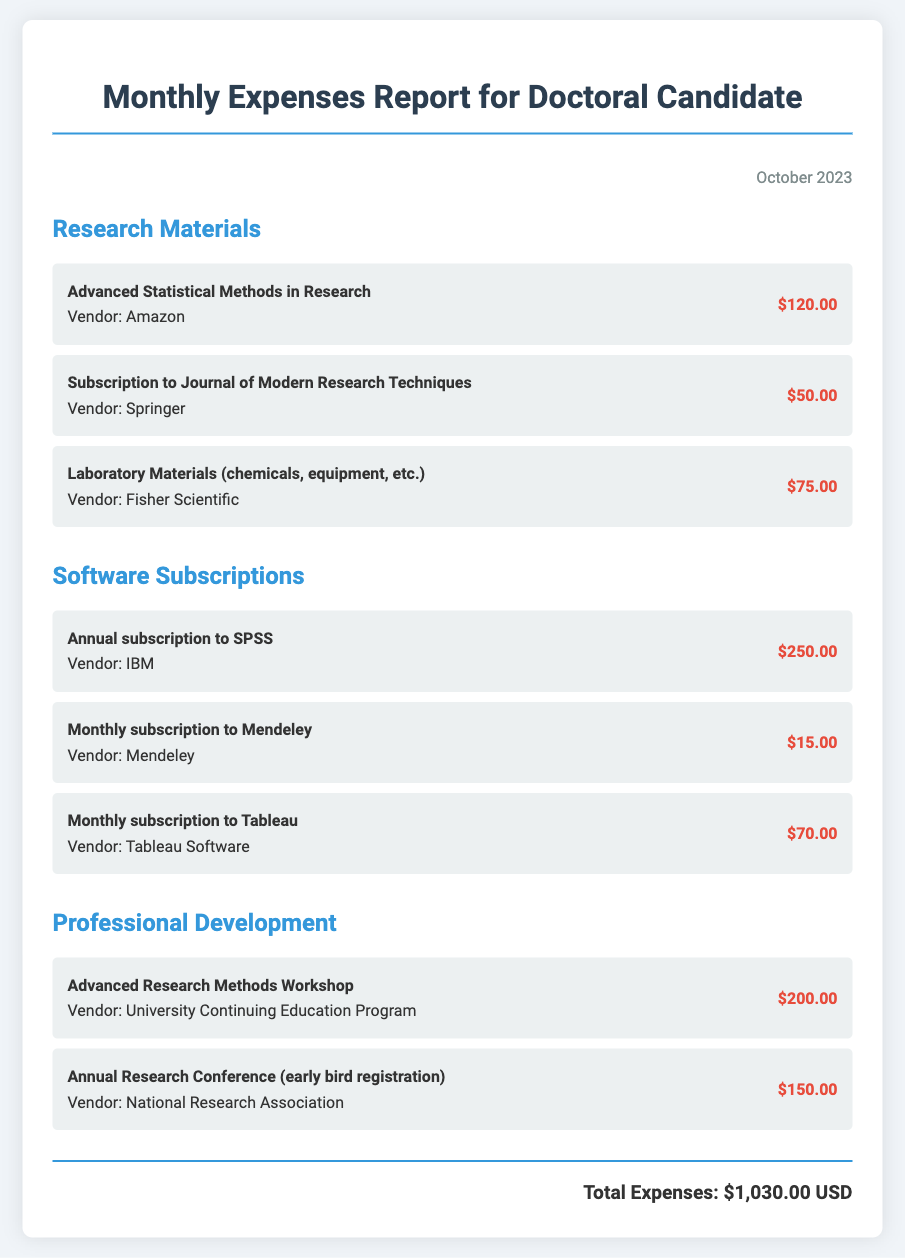What is the total amount spent on research materials? The total amount for research materials can be calculated by adding the individual expenses listed under that category: $120.00 + $50.00 + $75.00 = $245.00.
Answer: $245.00 How much is the monthly subscription to Mendeley? The monthly subscription to Mendeley is specifically mentioned in the document as $15.00.
Answer: $15.00 What is the cost of the Advanced Research Methods Workshop? The document states that the cost for the Advanced Research Methods Workshop is $200.00.
Answer: $200.00 Which vendor provided the Laboratory Materials? The expense for Laboratory Materials lists Fisher Scientific as the vendor.
Answer: Fisher Scientific How much was spent on professional development in total? To find the total spent on professional development, sum the costs: $200.00 + $150.00 = $350.00.
Answer: $350.00 What is the cost of the annual subscription to SPSS? The document indicates that the annual subscription to SPSS costs $250.00.
Answer: $250.00 What is the title of the journal for which a subscription was purchased? The subscription listed is for the Journal of Modern Research Techniques.
Answer: Journal of Modern Research Techniques How much were the total expenses for October 2023? The total expenses for October 2023 are summarized at the end of the document as $1,030.00.
Answer: $1,030.00 What is the date of the report? The document specifies that the date of the report is October 2023.
Answer: October 2023 